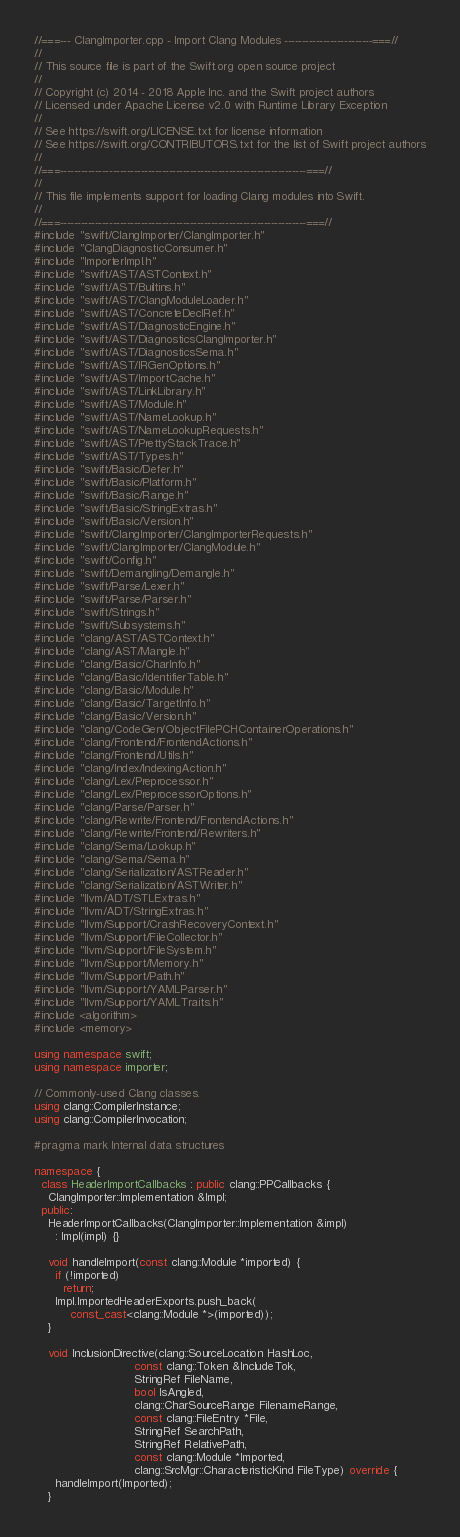Convert code to text. <code><loc_0><loc_0><loc_500><loc_500><_C++_>//===--- ClangImporter.cpp - Import Clang Modules -------------------------===//
//
// This source file is part of the Swift.org open source project
//
// Copyright (c) 2014 - 2018 Apple Inc. and the Swift project authors
// Licensed under Apache License v2.0 with Runtime Library Exception
//
// See https://swift.org/LICENSE.txt for license information
// See https://swift.org/CONTRIBUTORS.txt for the list of Swift project authors
//
//===----------------------------------------------------------------------===//
//
// This file implements support for loading Clang modules into Swift.
//
//===----------------------------------------------------------------------===//
#include "swift/ClangImporter/ClangImporter.h"
#include "ClangDiagnosticConsumer.h"
#include "ImporterImpl.h"
#include "swift/AST/ASTContext.h"
#include "swift/AST/Builtins.h"
#include "swift/AST/ClangModuleLoader.h"
#include "swift/AST/ConcreteDeclRef.h"
#include "swift/AST/DiagnosticEngine.h"
#include "swift/AST/DiagnosticsClangImporter.h"
#include "swift/AST/DiagnosticsSema.h"
#include "swift/AST/IRGenOptions.h"
#include "swift/AST/ImportCache.h"
#include "swift/AST/LinkLibrary.h"
#include "swift/AST/Module.h"
#include "swift/AST/NameLookup.h"
#include "swift/AST/NameLookupRequests.h"
#include "swift/AST/PrettyStackTrace.h"
#include "swift/AST/Types.h"
#include "swift/Basic/Defer.h"
#include "swift/Basic/Platform.h"
#include "swift/Basic/Range.h"
#include "swift/Basic/StringExtras.h"
#include "swift/Basic/Version.h"
#include "swift/ClangImporter/ClangImporterRequests.h"
#include "swift/ClangImporter/ClangModule.h"
#include "swift/Config.h"
#include "swift/Demangling/Demangle.h"
#include "swift/Parse/Lexer.h"
#include "swift/Parse/Parser.h"
#include "swift/Strings.h"
#include "swift/Subsystems.h"
#include "clang/AST/ASTContext.h"
#include "clang/AST/Mangle.h"
#include "clang/Basic/CharInfo.h"
#include "clang/Basic/IdentifierTable.h"
#include "clang/Basic/Module.h"
#include "clang/Basic/TargetInfo.h"
#include "clang/Basic/Version.h"
#include "clang/CodeGen/ObjectFilePCHContainerOperations.h"
#include "clang/Frontend/FrontendActions.h"
#include "clang/Frontend/Utils.h"
#include "clang/Index/IndexingAction.h"
#include "clang/Lex/Preprocessor.h"
#include "clang/Lex/PreprocessorOptions.h"
#include "clang/Parse/Parser.h"
#include "clang/Rewrite/Frontend/FrontendActions.h"
#include "clang/Rewrite/Frontend/Rewriters.h"
#include "clang/Sema/Lookup.h"
#include "clang/Sema/Sema.h"
#include "clang/Serialization/ASTReader.h"
#include "clang/Serialization/ASTWriter.h"
#include "llvm/ADT/STLExtras.h"
#include "llvm/ADT/StringExtras.h"
#include "llvm/Support/CrashRecoveryContext.h"
#include "llvm/Support/FileCollector.h"
#include "llvm/Support/FileSystem.h"
#include "llvm/Support/Memory.h"
#include "llvm/Support/Path.h"
#include "llvm/Support/YAMLParser.h"
#include "llvm/Support/YAMLTraits.h"
#include <algorithm>
#include <memory>

using namespace swift;
using namespace importer;

// Commonly-used Clang classes.
using clang::CompilerInstance;
using clang::CompilerInvocation;

#pragma mark Internal data structures

namespace {
  class HeaderImportCallbacks : public clang::PPCallbacks {
    ClangImporter::Implementation &Impl;
  public:
    HeaderImportCallbacks(ClangImporter::Implementation &impl)
      : Impl(impl) {}

    void handleImport(const clang::Module *imported) {
      if (!imported)
        return;
      Impl.ImportedHeaderExports.push_back(
          const_cast<clang::Module *>(imported));
    }

    void InclusionDirective(clang::SourceLocation HashLoc,
                            const clang::Token &IncludeTok,
                            StringRef FileName,
                            bool IsAngled,
                            clang::CharSourceRange FilenameRange,
                            const clang::FileEntry *File,
                            StringRef SearchPath,
                            StringRef RelativePath,
                            const clang::Module *Imported,
                            clang::SrcMgr::CharacteristicKind FileType) override {
      handleImport(Imported);
    }
</code> 